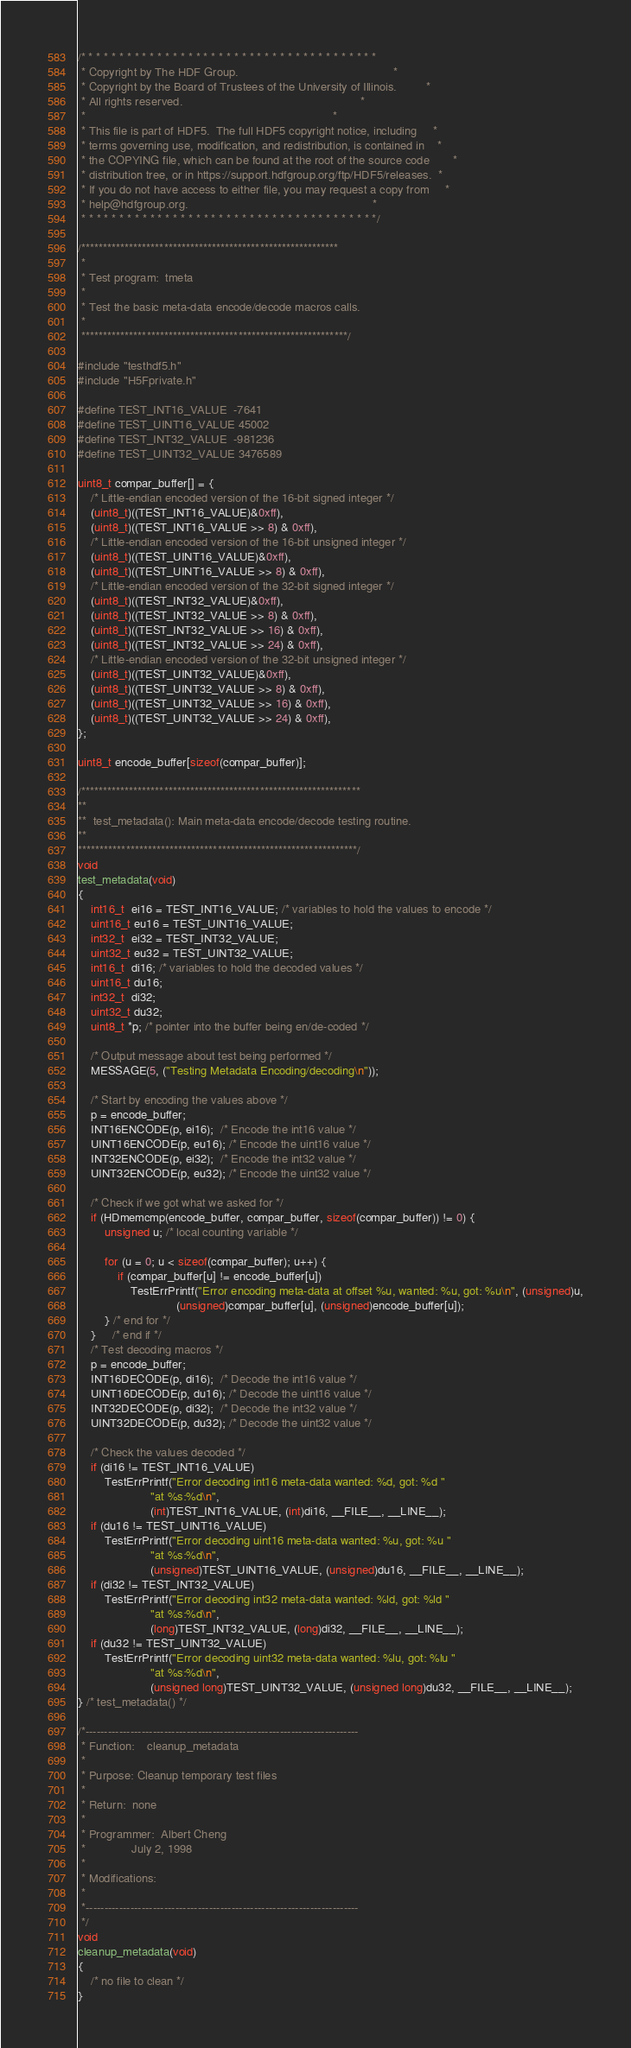Convert code to text. <code><loc_0><loc_0><loc_500><loc_500><_C_>/* * * * * * * * * * * * * * * * * * * * * * * * * * * * * * * * * * * * * * *
 * Copyright by The HDF Group.                                               *
 * Copyright by the Board of Trustees of the University of Illinois.         *
 * All rights reserved.                                                      *
 *                                                                           *
 * This file is part of HDF5.  The full HDF5 copyright notice, including     *
 * terms governing use, modification, and redistribution, is contained in    *
 * the COPYING file, which can be found at the root of the source code       *
 * distribution tree, or in https://support.hdfgroup.org/ftp/HDF5/releases.  *
 * If you do not have access to either file, you may request a copy from     *
 * help@hdfgroup.org.                                                        *
 * * * * * * * * * * * * * * * * * * * * * * * * * * * * * * * * * * * * * * */

/***********************************************************
 *
 * Test program:  tmeta
 *
 * Test the basic meta-data encode/decode macros calls.
 *
 *************************************************************/

#include "testhdf5.h"
#include "H5Fprivate.h"

#define TEST_INT16_VALUE  -7641
#define TEST_UINT16_VALUE 45002
#define TEST_INT32_VALUE  -981236
#define TEST_UINT32_VALUE 3476589

uint8_t compar_buffer[] = {
    /* Little-endian encoded version of the 16-bit signed integer */
    (uint8_t)((TEST_INT16_VALUE)&0xff),
    (uint8_t)((TEST_INT16_VALUE >> 8) & 0xff),
    /* Little-endian encoded version of the 16-bit unsigned integer */
    (uint8_t)((TEST_UINT16_VALUE)&0xff),
    (uint8_t)((TEST_UINT16_VALUE >> 8) & 0xff),
    /* Little-endian encoded version of the 32-bit signed integer */
    (uint8_t)((TEST_INT32_VALUE)&0xff),
    (uint8_t)((TEST_INT32_VALUE >> 8) & 0xff),
    (uint8_t)((TEST_INT32_VALUE >> 16) & 0xff),
    (uint8_t)((TEST_INT32_VALUE >> 24) & 0xff),
    /* Little-endian encoded version of the 32-bit unsigned integer */
    (uint8_t)((TEST_UINT32_VALUE)&0xff),
    (uint8_t)((TEST_UINT32_VALUE >> 8) & 0xff),
    (uint8_t)((TEST_UINT32_VALUE >> 16) & 0xff),
    (uint8_t)((TEST_UINT32_VALUE >> 24) & 0xff),
};

uint8_t encode_buffer[sizeof(compar_buffer)];

/****************************************************************
**
**  test_metadata(): Main meta-data encode/decode testing routine.
**
****************************************************************/
void
test_metadata(void)
{
    int16_t  ei16 = TEST_INT16_VALUE; /* variables to hold the values to encode */
    uint16_t eu16 = TEST_UINT16_VALUE;
    int32_t  ei32 = TEST_INT32_VALUE;
    uint32_t eu32 = TEST_UINT32_VALUE;
    int16_t  di16; /* variables to hold the decoded values */
    uint16_t du16;
    int32_t  di32;
    uint32_t du32;
    uint8_t *p; /* pointer into the buffer being en/de-coded */

    /* Output message about test being performed */
    MESSAGE(5, ("Testing Metadata Encoding/decoding\n"));

    /* Start by encoding the values above */
    p = encode_buffer;
    INT16ENCODE(p, ei16);  /* Encode the int16 value */
    UINT16ENCODE(p, eu16); /* Encode the uint16 value */
    INT32ENCODE(p, ei32);  /* Encode the int32 value */
    UINT32ENCODE(p, eu32); /* Encode the uint32 value */

    /* Check if we got what we asked for */
    if (HDmemcmp(encode_buffer, compar_buffer, sizeof(compar_buffer)) != 0) {
        unsigned u; /* local counting variable */

        for (u = 0; u < sizeof(compar_buffer); u++) {
            if (compar_buffer[u] != encode_buffer[u])
                TestErrPrintf("Error encoding meta-data at offset %u, wanted: %u, got: %u\n", (unsigned)u,
                              (unsigned)compar_buffer[u], (unsigned)encode_buffer[u]);
        } /* end for */
    }     /* end if */
    /* Test decoding macros */
    p = encode_buffer;
    INT16DECODE(p, di16);  /* Decode the int16 value */
    UINT16DECODE(p, du16); /* Decode the uint16 value */
    INT32DECODE(p, di32);  /* Decode the int32 value */
    UINT32DECODE(p, du32); /* Decode the uint32 value */

    /* Check the values decoded */
    if (di16 != TEST_INT16_VALUE)
        TestErrPrintf("Error decoding int16 meta-data wanted: %d, got: %d "
                      "at %s:%d\n",
                      (int)TEST_INT16_VALUE, (int)di16, __FILE__, __LINE__);
    if (du16 != TEST_UINT16_VALUE)
        TestErrPrintf("Error decoding uint16 meta-data wanted: %u, got: %u "
                      "at %s:%d\n",
                      (unsigned)TEST_UINT16_VALUE, (unsigned)du16, __FILE__, __LINE__);
    if (di32 != TEST_INT32_VALUE)
        TestErrPrintf("Error decoding int32 meta-data wanted: %ld, got: %ld "
                      "at %s:%d\n",
                      (long)TEST_INT32_VALUE, (long)di32, __FILE__, __LINE__);
    if (du32 != TEST_UINT32_VALUE)
        TestErrPrintf("Error decoding uint32 meta-data wanted: %lu, got: %lu "
                      "at %s:%d\n",
                      (unsigned long)TEST_UINT32_VALUE, (unsigned long)du32, __FILE__, __LINE__);
} /* test_metadata() */

/*-------------------------------------------------------------------------
 * Function:	cleanup_metadata
 *
 * Purpose:	Cleanup temporary test files
 *
 * Return:	none
 *
 * Programmer:	Albert Cheng
 *              July 2, 1998
 *
 * Modifications:
 *
 *-------------------------------------------------------------------------
 */
void
cleanup_metadata(void)
{
    /* no file to clean */
}
</code> 